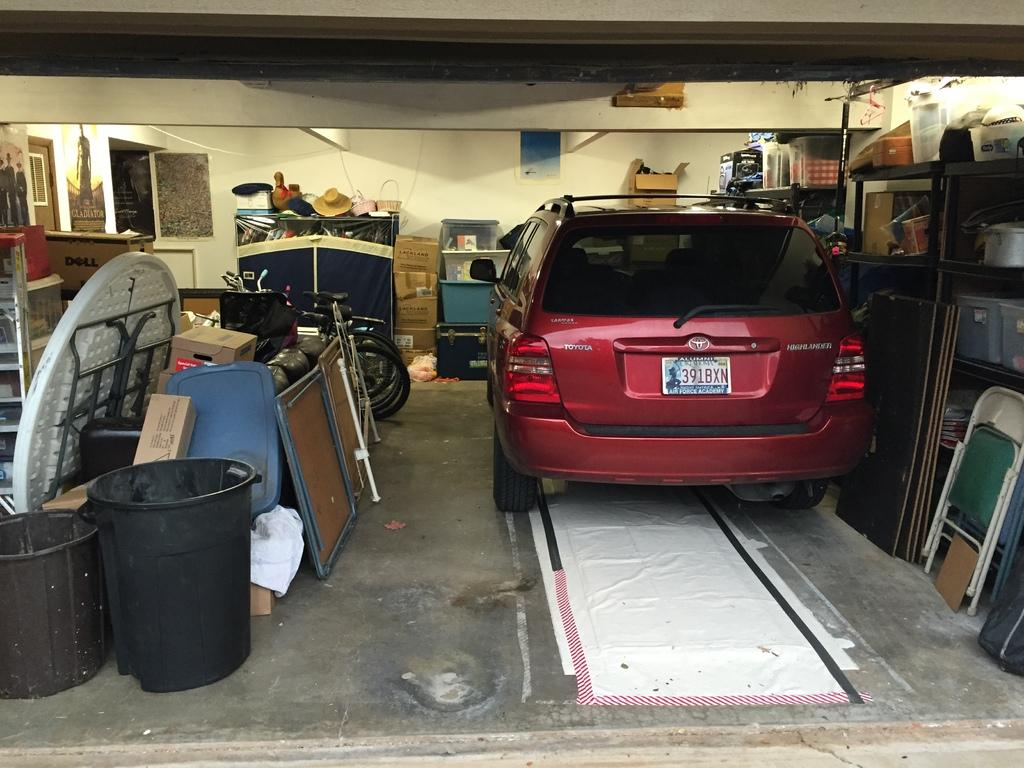What type of vehicle can be seen in the image? There is a car in the image. What type of furniture is present in the image? There are chairs in the image. What can be found on shelves in the image? Objects are placed on shelves in the image. What type of audio equipment is visible in the image? There are speakers in the image. What device is used for air circulation in the image? A ventilator is present in the image. What type of decorative items are in the image? There are posters in the image. What type of table is visible in the image? A dining table is visible in the image. What type of storage containers are present in the image? Containers are present in the image. What type of transportation can be seen in the image? Bicycles are in the image. What type of lighting is present in the image? There is a light in the image. What type of architectural feature is visible in the image? A wall is visible in the image. How much profit does the downtown rest area make in the image? There is no mention of a downtown rest area or profit in the image. The image features a car, chairs, shelves, speakers, a ventilator, posters, a dining table, containers, bicycles, a light, and a wall. 